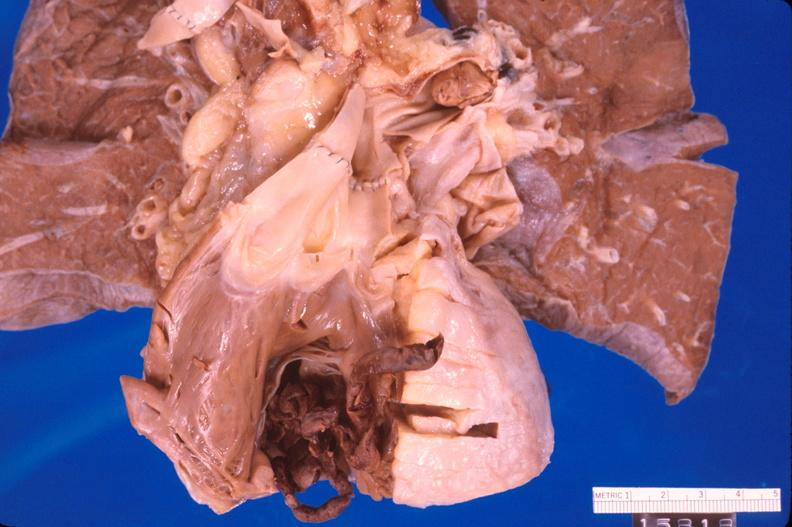s cardiovascular present?
Answer the question using a single word or phrase. Yes 